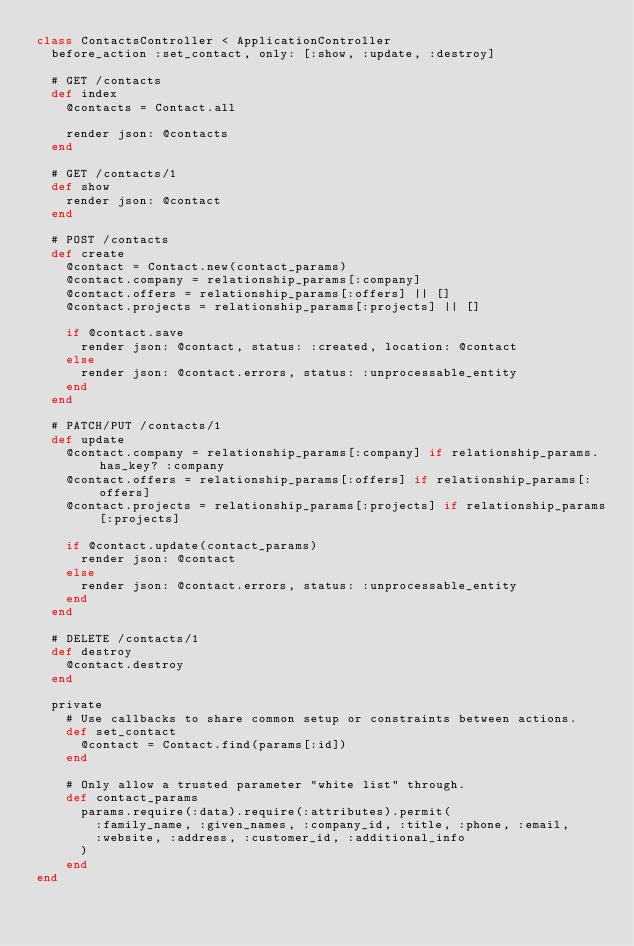<code> <loc_0><loc_0><loc_500><loc_500><_Ruby_>class ContactsController < ApplicationController
  before_action :set_contact, only: [:show, :update, :destroy]

  # GET /contacts
  def index
    @contacts = Contact.all

    render json: @contacts
  end

  # GET /contacts/1
  def show
    render json: @contact
  end

  # POST /contacts
  def create
    @contact = Contact.new(contact_params)
    @contact.company = relationship_params[:company]
    @contact.offers = relationship_params[:offers] || []
    @contact.projects = relationship_params[:projects] || []

    if @contact.save
      render json: @contact, status: :created, location: @contact
    else
      render json: @contact.errors, status: :unprocessable_entity
    end
  end

  # PATCH/PUT /contacts/1
  def update
    @contact.company = relationship_params[:company] if relationship_params.has_key? :company
    @contact.offers = relationship_params[:offers] if relationship_params[:offers]
    @contact.projects = relationship_params[:projects] if relationship_params[:projects]

    if @contact.update(contact_params)
      render json: @contact
    else
      render json: @contact.errors, status: :unprocessable_entity
    end
  end

  # DELETE /contacts/1
  def destroy
    @contact.destroy
  end

  private
    # Use callbacks to share common setup or constraints between actions.
    def set_contact
      @contact = Contact.find(params[:id])
    end

    # Only allow a trusted parameter "white list" through.
    def contact_params
      params.require(:data).require(:attributes).permit(
        :family_name, :given_names, :company_id, :title, :phone, :email,
        :website, :address, :customer_id, :additional_info
      )
    end
end
</code> 